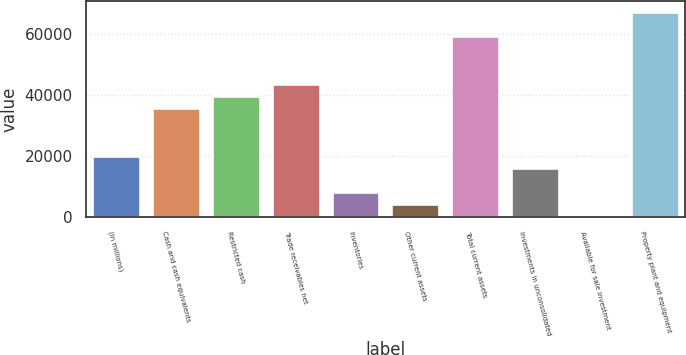Convert chart to OTSL. <chart><loc_0><loc_0><loc_500><loc_500><bar_chart><fcel>(in millions)<fcel>Cash and cash equivalents<fcel>Restricted cash<fcel>Trade receivables net<fcel>Inventories<fcel>Other current assets<fcel>Total current assets<fcel>Investments in unconsolidated<fcel>Available for sale investment<fcel>Property plant and equipment<nl><fcel>20062<fcel>35796.4<fcel>39730<fcel>43663.6<fcel>8261.2<fcel>4327.6<fcel>59398<fcel>16128.4<fcel>394<fcel>67265.2<nl></chart> 